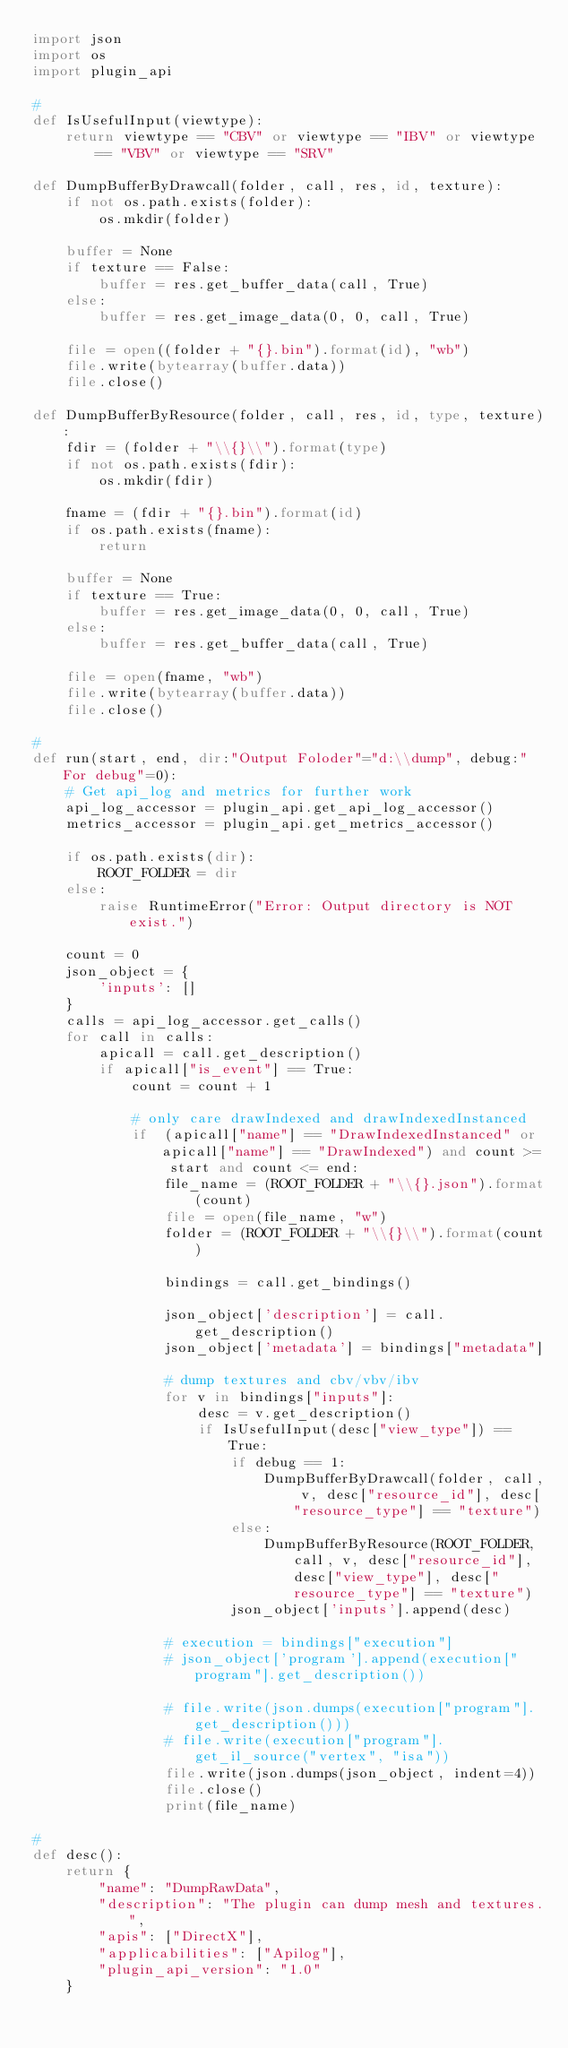Convert code to text. <code><loc_0><loc_0><loc_500><loc_500><_Python_>import json
import os
import plugin_api

#
def IsUsefulInput(viewtype):
    return viewtype == "CBV" or viewtype == "IBV" or viewtype == "VBV" or viewtype == "SRV"

def DumpBufferByDrawcall(folder, call, res, id, texture):
    if not os.path.exists(folder):
        os.mkdir(folder)

    buffer = None
    if texture == False:
        buffer = res.get_buffer_data(call, True)
    else:
        buffer = res.get_image_data(0, 0, call, True)
    
    file = open((folder + "{}.bin").format(id), "wb")
    file.write(bytearray(buffer.data))
    file.close()

def DumpBufferByResource(folder, call, res, id, type, texture):
    fdir = (folder + "\\{}\\").format(type)
    if not os.path.exists(fdir):
        os.mkdir(fdir)

    fname = (fdir + "{}.bin").format(id)
    if os.path.exists(fname):
        return

    buffer = None
    if texture == True:
        buffer = res.get_image_data(0, 0, call, True)
    else:
        buffer = res.get_buffer_data(call, True)

    file = open(fname, "wb")
    file.write(bytearray(buffer.data))
    file.close()

#
def run(start, end, dir:"Output Foloder"="d:\\dump", debug:"For debug"=0):
    # Get api_log and metrics for further work
    api_log_accessor = plugin_api.get_api_log_accessor()
    metrics_accessor = plugin_api.get_metrics_accessor()

    if os.path.exists(dir):
        ROOT_FOLDER = dir
    else:
        raise RuntimeError("Error: Output directory is NOT exist.")

    count = 0
    json_object = {
        'inputs': []
    }
    calls = api_log_accessor.get_calls()
    for call in calls:
        apicall = call.get_description()
        if apicall["is_event"] == True:
            count = count + 1

            # only care drawIndexed and drawIndexedInstanced
            if  (apicall["name"] == "DrawIndexedInstanced" or apicall["name"] == "DrawIndexed") and count >= start and count <= end:
                file_name = (ROOT_FOLDER + "\\{}.json").format(count)
                file = open(file_name, "w")
                folder = (ROOT_FOLDER + "\\{}\\").format(count)

                bindings = call.get_bindings()

                json_object['description'] = call.get_description()
                json_object['metadata'] = bindings["metadata"]

                # dump textures and cbv/vbv/ibv
                for v in bindings["inputs"]:
                    desc = v.get_description()
                    if IsUsefulInput(desc["view_type"]) == True:
                        if debug == 1:
                            DumpBufferByDrawcall(folder, call, v, desc["resource_id"], desc["resource_type"] == "texture")
                        else:
                            DumpBufferByResource(ROOT_FOLDER, call, v, desc["resource_id"], desc["view_type"], desc["resource_type"] == "texture")
                        json_object['inputs'].append(desc)

                # execution = bindings["execution"]
                # json_object['program'].append(execution["program"].get_description())

                # file.write(json.dumps(execution["program"].get_description()))
                # file.write(execution["program"].get_il_source("vertex", "isa"))
                file.write(json.dumps(json_object, indent=4))
                file.close()
                print(file_name)

#
def desc():
    return {
        "name": "DumpRawData",
        "description": "The plugin can dump mesh and textures.",
        "apis": ["DirectX"],
        "applicabilities": ["Apilog"],
        "plugin_api_version": "1.0"
    }
</code> 